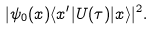Convert formula to latex. <formula><loc_0><loc_0><loc_500><loc_500>| \psi _ { 0 } ( x ) \langle x ^ { \prime } | U ( \tau ) | x \rangle | ^ { 2 } .</formula> 